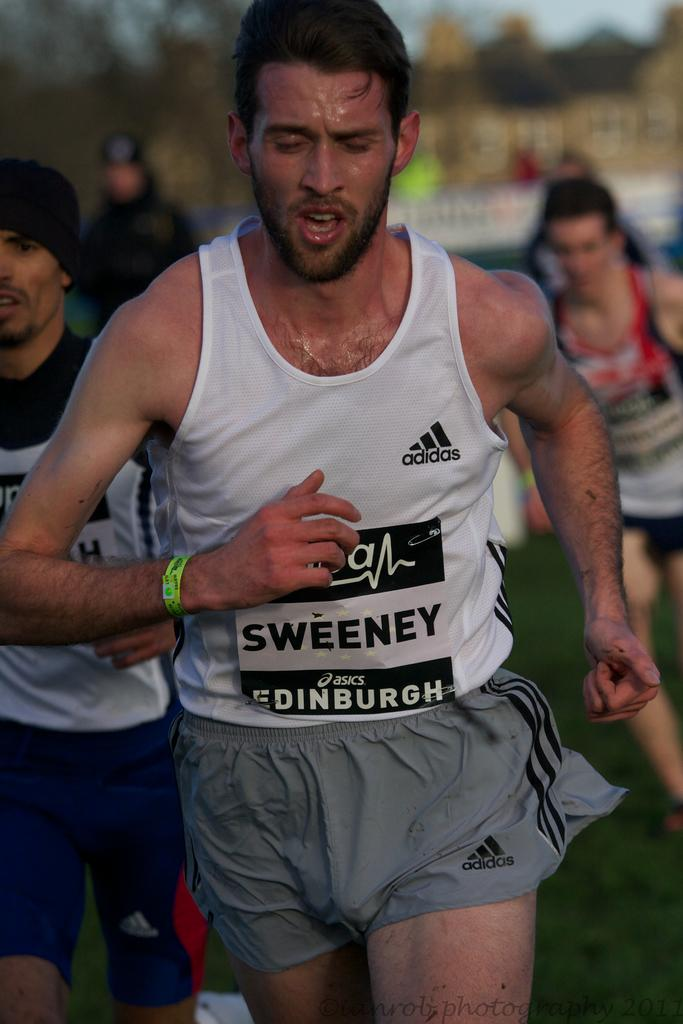What are the people in the image doing? The people in the image are running. Can you describe the background of the image? The background of the image is blurred. What type of corn is being used as a prop in the image? There is no corn present in the image. What time of day is depicted in the image? The provided facts do not give any information about the time of day in the image. 